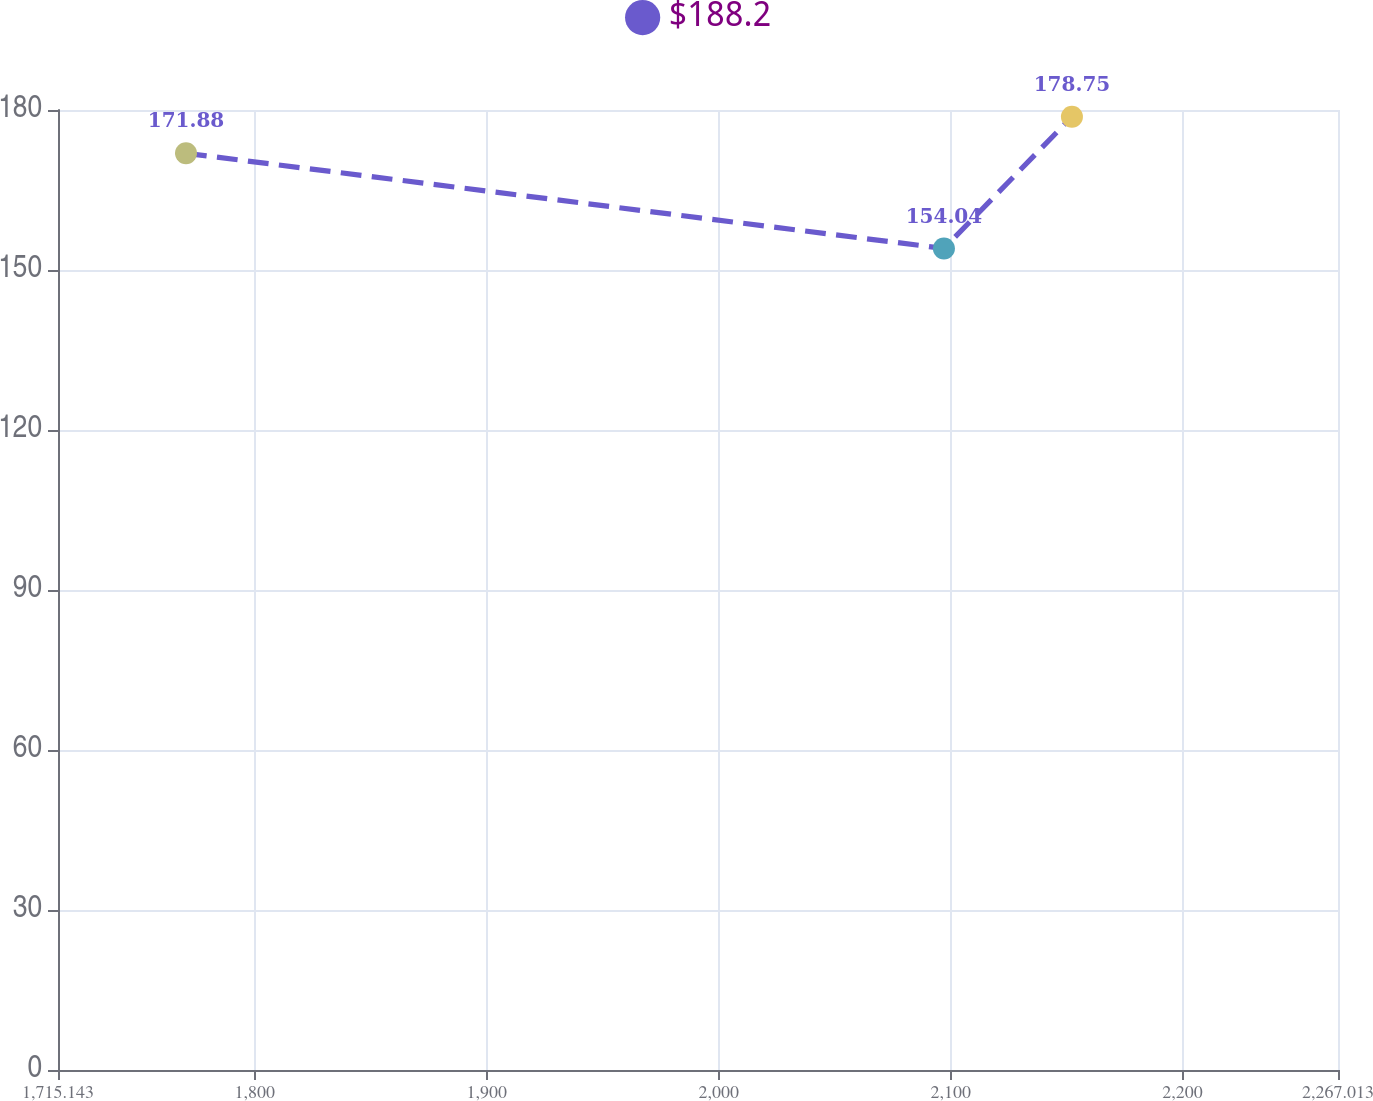Convert chart. <chart><loc_0><loc_0><loc_500><loc_500><line_chart><ecel><fcel>$188.2<nl><fcel>1770.33<fcel>171.88<nl><fcel>2097.11<fcel>154.04<nl><fcel>2152.3<fcel>178.75<nl><fcel>2322.2<fcel>205.05<nl></chart> 